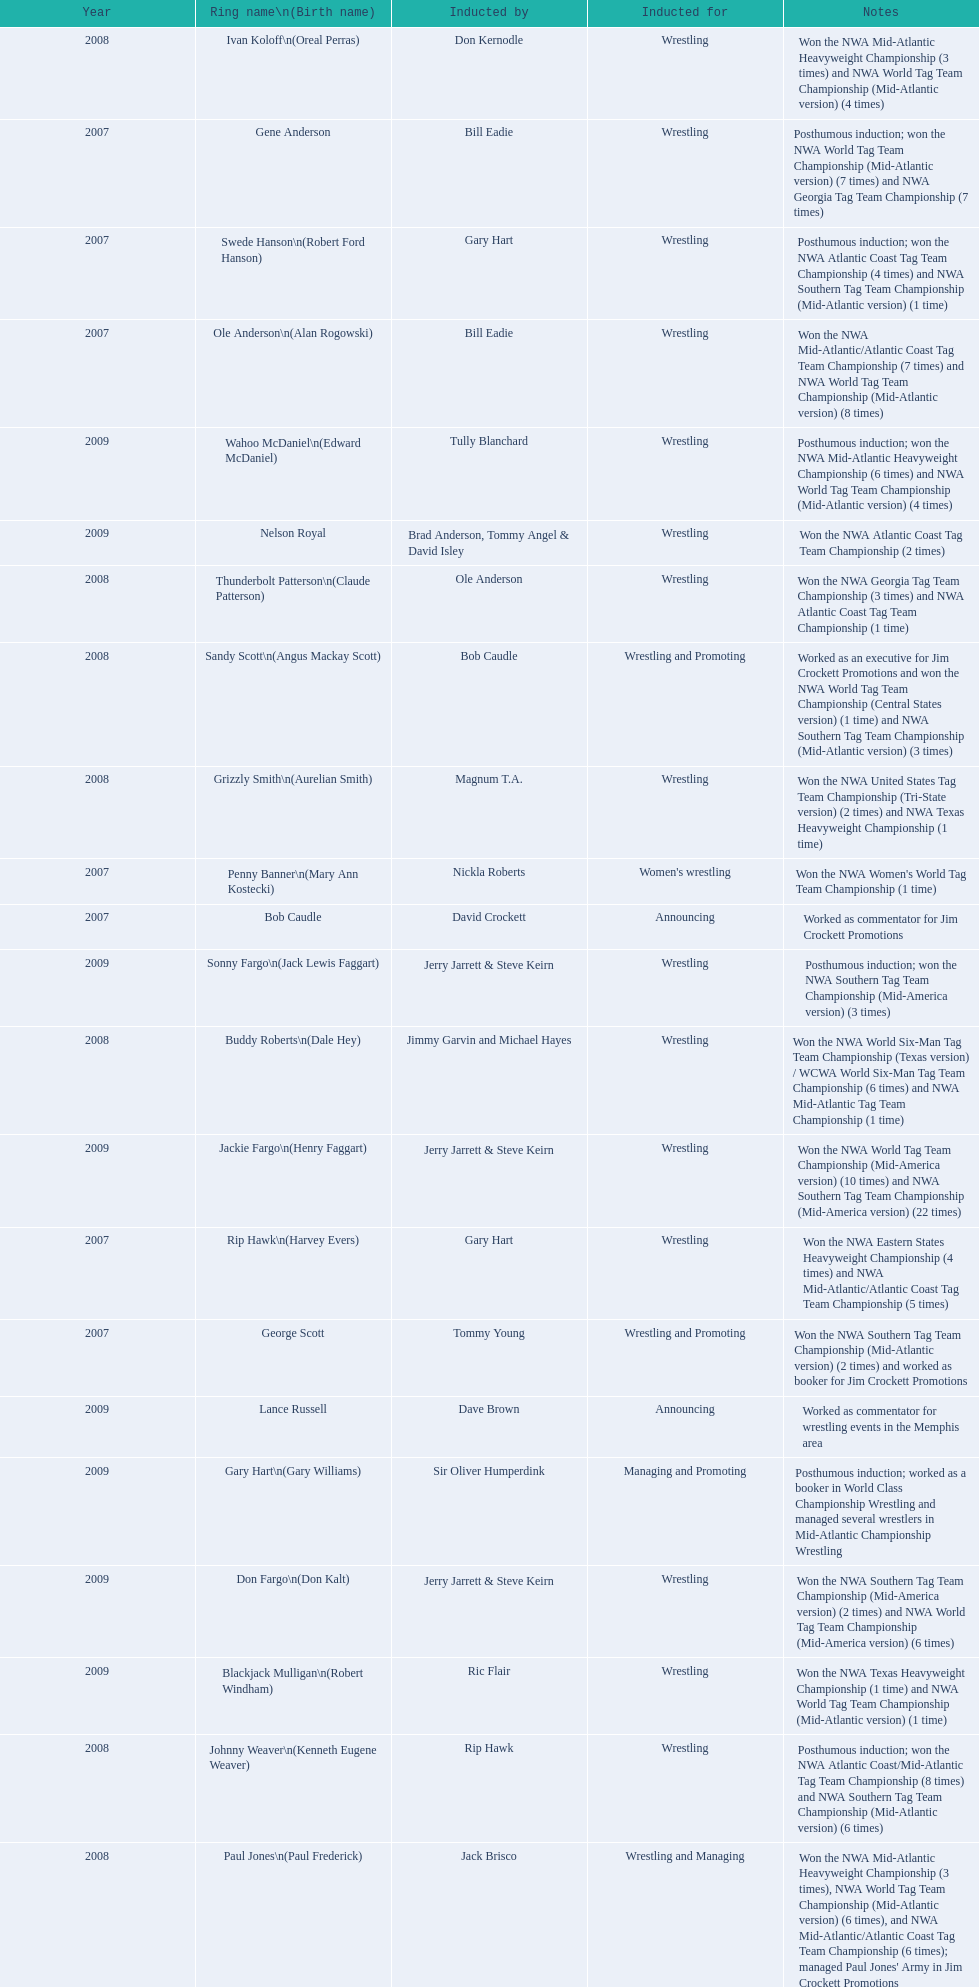What announcers were inducted? Bob Caudle, Lance Russell. What announcer was inducted in 2009? Lance Russell. 